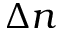Convert formula to latex. <formula><loc_0><loc_0><loc_500><loc_500>\Delta n</formula> 